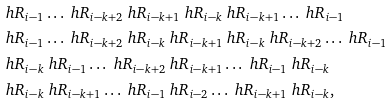Convert formula to latex. <formula><loc_0><loc_0><loc_500><loc_500>& \ h R _ { i - 1 } \dots \ h R _ { i - k + 2 } \ h R _ { i - k + 1 } \ h R _ { i - k } \ h R _ { i - k + 1 } \dots \ h R _ { i - 1 } \\ & \ h R _ { i - 1 } \dots \ h R _ { i - k + 2 } \ h R _ { i - k } \ h R _ { i - k + 1 } \ h R _ { i - k } \ h R _ { i - k + 2 } \dots \ h R _ { i - 1 } \\ & \ h R _ { i - k } \ h R _ { i - 1 } \dots \ h R _ { i - k + 2 } \ h R _ { i - k + 1 } \dots \ h R _ { i - 1 } \ h R _ { i - k } \\ & \ h R _ { i - k } \ h R _ { i - k + 1 } \dots \ h R _ { i - 1 } \ h R _ { i - 2 } \dots \ h R _ { i - k + 1 } \ h R _ { i - k } ,</formula> 